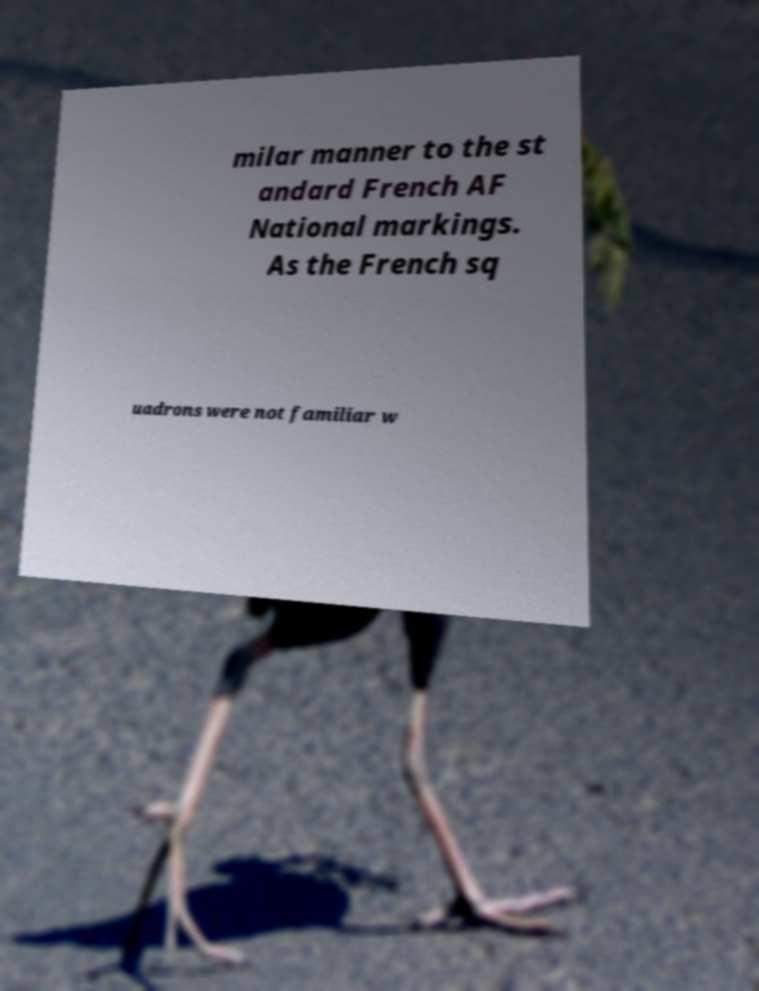Can you accurately transcribe the text from the provided image for me? milar manner to the st andard French AF National markings. As the French sq uadrons were not familiar w 